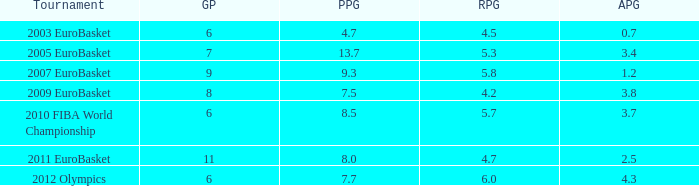How many points per game have the tournament 2005 eurobasket? 13.7. 